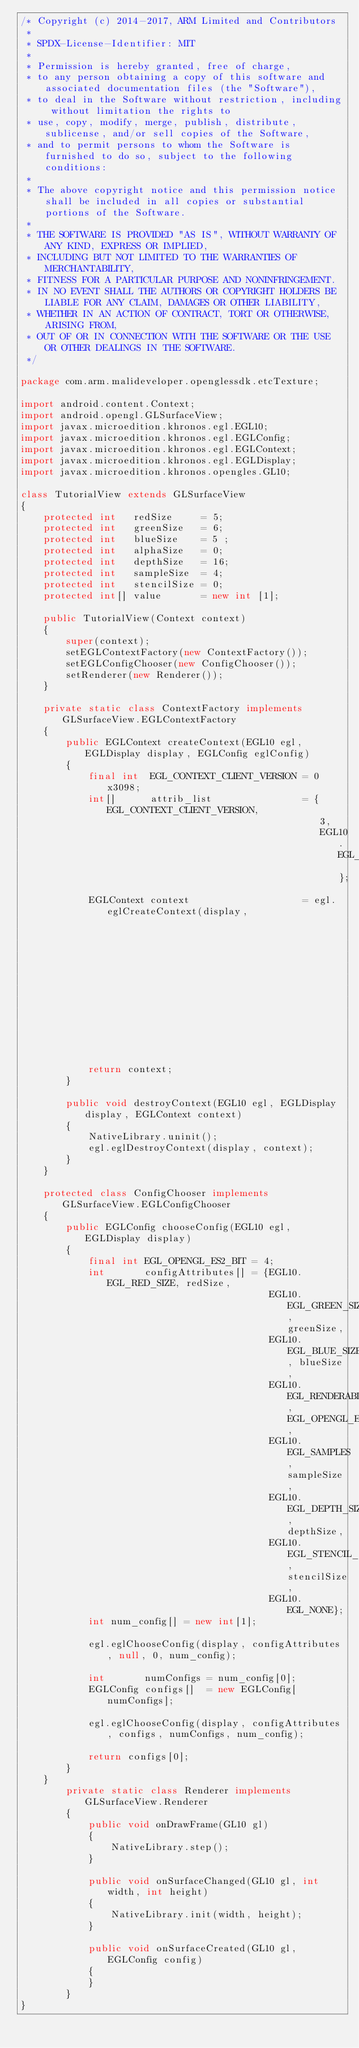Convert code to text. <code><loc_0><loc_0><loc_500><loc_500><_Java_>/* Copyright (c) 2014-2017, ARM Limited and Contributors
 *
 * SPDX-License-Identifier: MIT
 *
 * Permission is hereby granted, free of charge,
 * to any person obtaining a copy of this software and associated documentation files (the "Software"),
 * to deal in the Software without restriction, including without limitation the rights to
 * use, copy, modify, merge, publish, distribute, sublicense, and/or sell copies of the Software,
 * and to permit persons to whom the Software is furnished to do so, subject to the following conditions:
 *
 * The above copyright notice and this permission notice shall be included in all copies or substantial portions of the Software.
 *
 * THE SOFTWARE IS PROVIDED "AS IS", WITHOUT WARRANTY OF ANY KIND, EXPRESS OR IMPLIED,
 * INCLUDING BUT NOT LIMITED TO THE WARRANTIES OF MERCHANTABILITY,
 * FITNESS FOR A PARTICULAR PURPOSE AND NONINFRINGEMENT.
 * IN NO EVENT SHALL THE AUTHORS OR COPYRIGHT HOLDERS BE LIABLE FOR ANY CLAIM, DAMAGES OR OTHER LIABILITY,
 * WHETHER IN AN ACTION OF CONTRACT, TORT OR OTHERWISE, ARISING FROM,
 * OUT OF OR IN CONNECTION WITH THE SOFTWARE OR THE USE OR OTHER DEALINGS IN THE SOFTWARE.
 */

package com.arm.malideveloper.openglessdk.etcTexture;

import android.content.Context;
import android.opengl.GLSurfaceView;
import javax.microedition.khronos.egl.EGL10;
import javax.microedition.khronos.egl.EGLConfig;
import javax.microedition.khronos.egl.EGLContext;
import javax.microedition.khronos.egl.EGLDisplay;
import javax.microedition.khronos.opengles.GL10;

class TutorialView extends GLSurfaceView
{
    protected int   redSize     = 5;
    protected int   greenSize   = 6;
    protected int   blueSize    = 5 ;
    protected int   alphaSize   = 0;
    protected int   depthSize   = 16;
    protected int   sampleSize  = 4;
    protected int   stencilSize = 0;
    protected int[] value       = new int [1];

    public TutorialView(Context context)
    {
        super(context);
        setEGLContextFactory(new ContextFactory());
        setEGLConfigChooser(new ConfigChooser());
        setRenderer(new Renderer());
    }

    private static class ContextFactory implements GLSurfaceView.EGLContextFactory
    {
        public EGLContext createContext(EGL10 egl, EGLDisplay display, EGLConfig eglConfig)
        {
            final int  EGL_CONTEXT_CLIENT_VERSION = 0x3098;
            int[]      attrib_list                = {EGL_CONTEXT_CLIENT_VERSION,
                                                     3,
                                                     EGL10.EGL_NONE };
            EGLContext context                    = egl.eglCreateContext(display,
                                                                         eglConfig,
                                                                         EGL10.EGL_NO_CONTEXT,
                                                                         attrib_list);

            return context;
        }

        public void destroyContext(EGL10 egl, EGLDisplay display, EGLContext context)
        {
            NativeLibrary.uninit();
            egl.eglDestroyContext(display, context);
        }
    }

    protected class ConfigChooser implements GLSurfaceView.EGLConfigChooser
    {
        public EGLConfig chooseConfig(EGL10 egl, EGLDisplay display)
        {
        	final int EGL_OPENGL_ES2_BIT = 4;
        	int       configAttributes[] = {EGL10.EGL_RED_SIZE, redSize,
                                            EGL10.EGL_GREEN_SIZE, greenSize,
                                            EGL10.EGL_BLUE_SIZE, blueSize,
                                            EGL10.EGL_RENDERABLE_TYPE, EGL_OPENGL_ES2_BIT,
                                            EGL10.EGL_SAMPLES, sampleSize,
                                            EGL10.EGL_DEPTH_SIZE, depthSize,
                                            EGL10.EGL_STENCIL_SIZE, stencilSize,
                                            EGL10.EGL_NONE};
            int num_config[] = new int[1];

            egl.eglChooseConfig(display, configAttributes, null, 0, num_config);

            int       numConfigs = num_config[0];
            EGLConfig configs[]  = new EGLConfig[numConfigs];

            egl.eglChooseConfig(display, configAttributes, configs, numConfigs, num_config);

            return configs[0];
        }
    }
        private static class Renderer implements GLSurfaceView.Renderer
        {
            public void onDrawFrame(GL10 gl)
            {
                NativeLibrary.step();
            }

            public void onSurfaceChanged(GL10 gl, int width, int height)
            {
                NativeLibrary.init(width, height);
            }

            public void onSurfaceCreated(GL10 gl, EGLConfig config)
            {
            }
        }
}</code> 